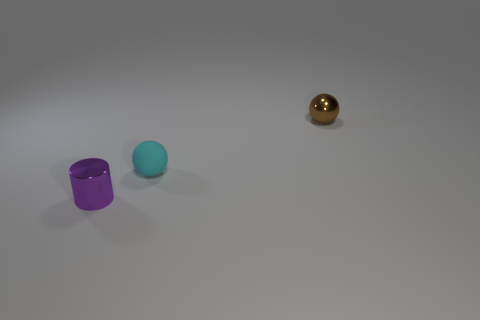Add 2 tiny cyan matte objects. How many objects exist? 5 Subtract all spheres. How many objects are left? 1 Subtract 1 cyan balls. How many objects are left? 2 Subtract all small yellow rubber cylinders. Subtract all shiny things. How many objects are left? 1 Add 2 tiny cyan matte objects. How many tiny cyan matte objects are left? 3 Add 1 large red cylinders. How many large red cylinders exist? 1 